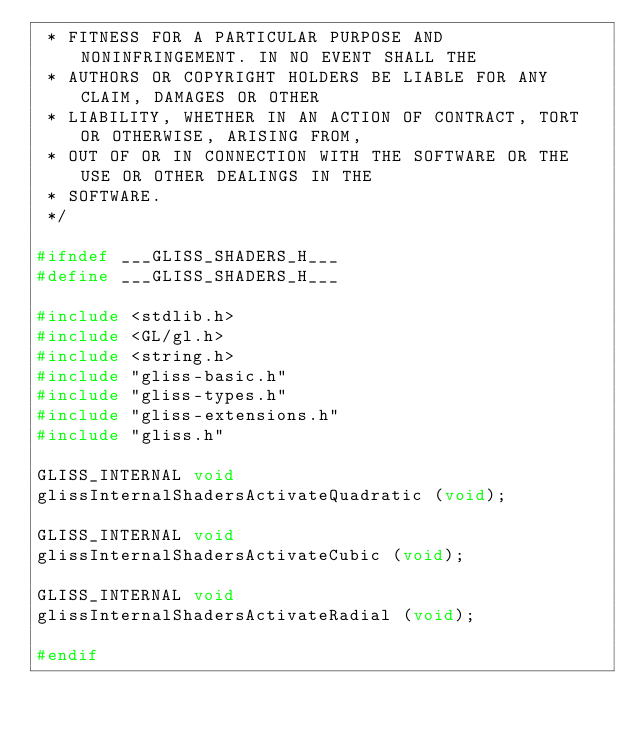Convert code to text. <code><loc_0><loc_0><loc_500><loc_500><_C_> * FITNESS FOR A PARTICULAR PURPOSE AND NONINFRINGEMENT. IN NO EVENT SHALL THE
 * AUTHORS OR COPYRIGHT HOLDERS BE LIABLE FOR ANY CLAIM, DAMAGES OR OTHER
 * LIABILITY, WHETHER IN AN ACTION OF CONTRACT, TORT OR OTHERWISE, ARISING FROM,
 * OUT OF OR IN CONNECTION WITH THE SOFTWARE OR THE USE OR OTHER DEALINGS IN THE
 * SOFTWARE.
 */

#ifndef ___GLISS_SHADERS_H___
#define ___GLISS_SHADERS_H___

#include <stdlib.h>
#include <GL/gl.h>
#include <string.h>
#include "gliss-basic.h"
#include "gliss-types.h"
#include "gliss-extensions.h"
#include "gliss.h"

GLISS_INTERNAL void
glissInternalShadersActivateQuadratic (void);

GLISS_INTERNAL void
glissInternalShadersActivateCubic (void);

GLISS_INTERNAL void
glissInternalShadersActivateRadial (void);

#endif

</code> 